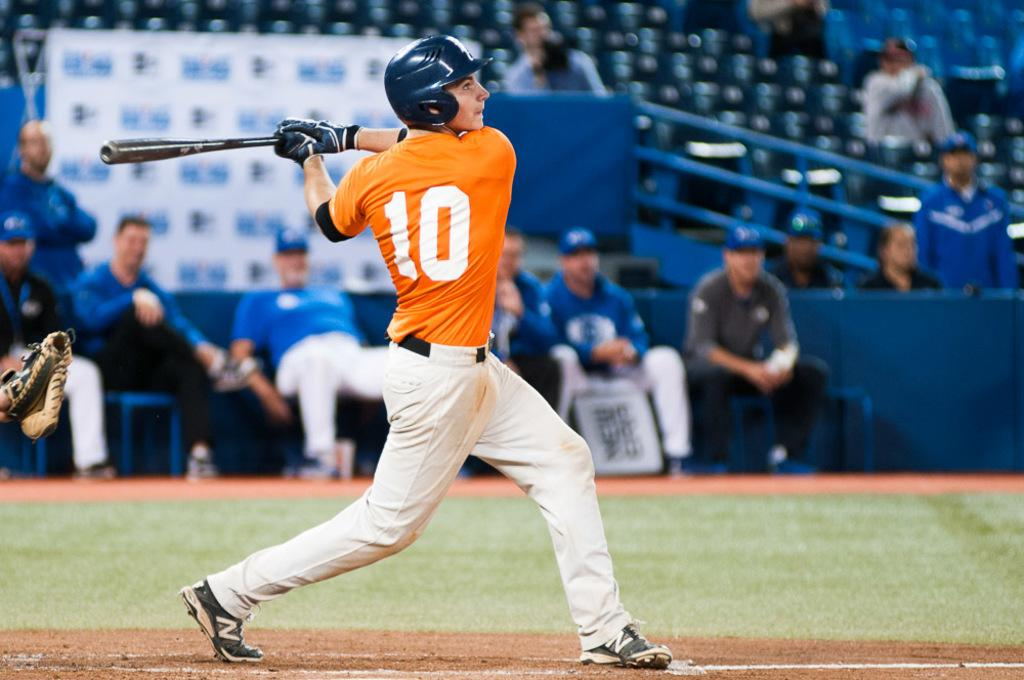<image>
Offer a succinct explanation of the picture presented. A batter wearing an orange shirt with the number 10 on it. 